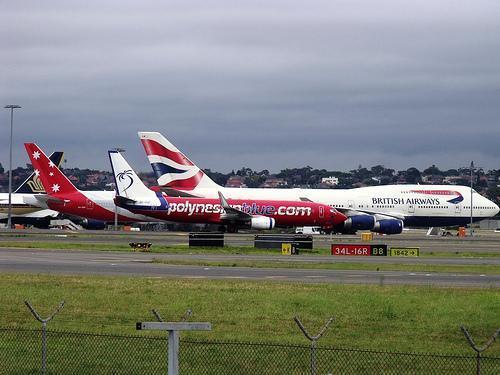How many planes are there?
Give a very brief answer. 4. 